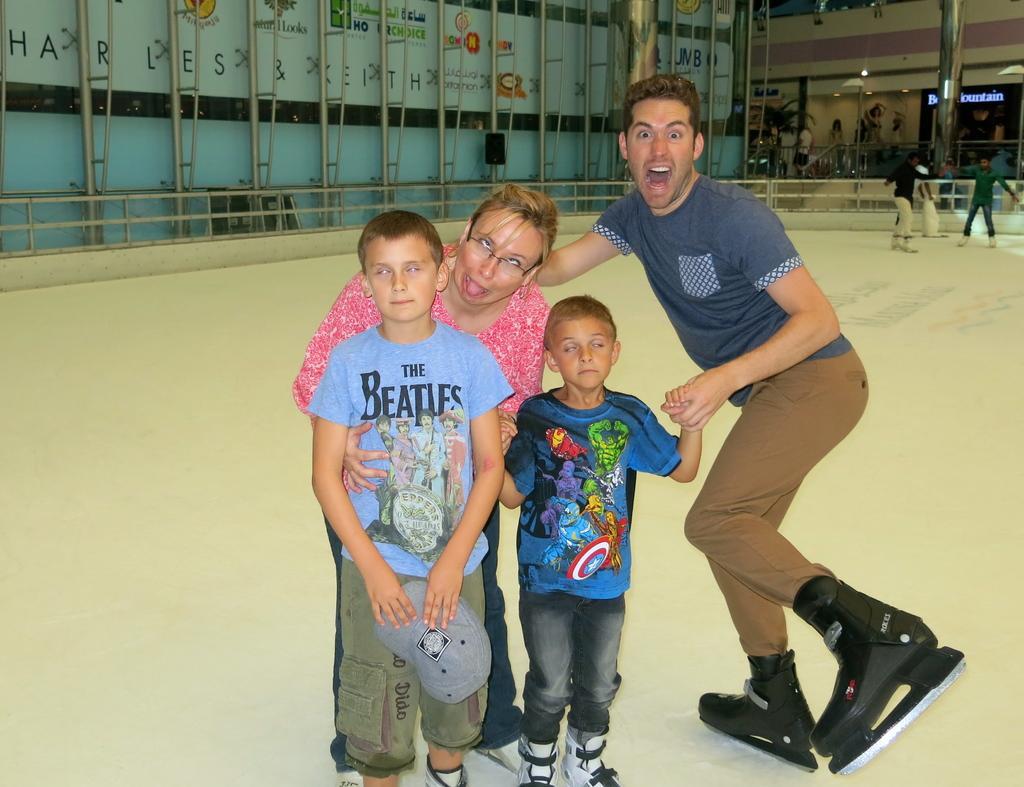Can you describe this image briefly? In this image we can see a male, female and two persons standing in the foreground of the image posing for a photograph and in the background of the image there are some persons standing on floor and there are some pipes, fencing and there is a wall. 